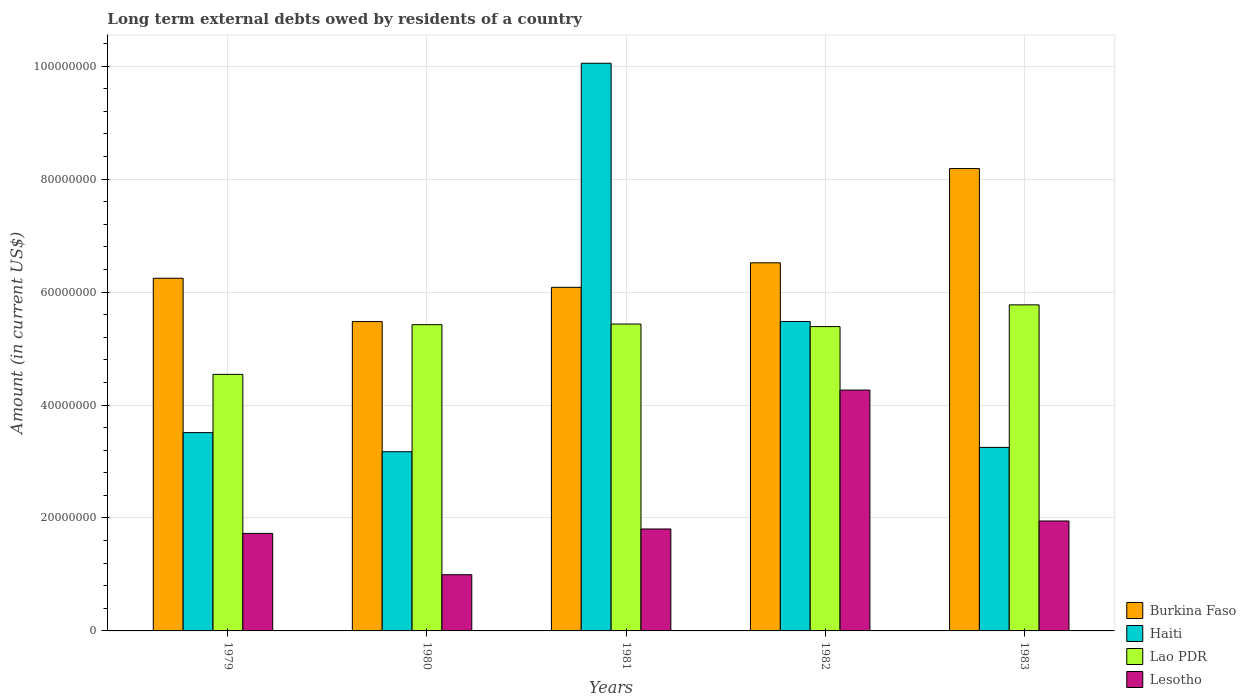How many different coloured bars are there?
Give a very brief answer. 4. How many groups of bars are there?
Your answer should be very brief. 5. Are the number of bars on each tick of the X-axis equal?
Keep it short and to the point. Yes. How many bars are there on the 3rd tick from the left?
Your answer should be compact. 4. What is the amount of long-term external debts owed by residents in Burkina Faso in 1982?
Give a very brief answer. 6.52e+07. Across all years, what is the maximum amount of long-term external debts owed by residents in Lao PDR?
Provide a short and direct response. 5.77e+07. Across all years, what is the minimum amount of long-term external debts owed by residents in Lao PDR?
Offer a very short reply. 4.54e+07. In which year was the amount of long-term external debts owed by residents in Lesotho minimum?
Your answer should be compact. 1980. What is the total amount of long-term external debts owed by residents in Haiti in the graph?
Your response must be concise. 2.55e+08. What is the difference between the amount of long-term external debts owed by residents in Lao PDR in 1982 and that in 1983?
Offer a terse response. -3.85e+06. What is the difference between the amount of long-term external debts owed by residents in Lao PDR in 1981 and the amount of long-term external debts owed by residents in Haiti in 1983?
Ensure brevity in your answer.  2.18e+07. What is the average amount of long-term external debts owed by residents in Haiti per year?
Ensure brevity in your answer.  5.09e+07. In the year 1982, what is the difference between the amount of long-term external debts owed by residents in Burkina Faso and amount of long-term external debts owed by residents in Haiti?
Your answer should be compact. 1.04e+07. In how many years, is the amount of long-term external debts owed by residents in Haiti greater than 68000000 US$?
Ensure brevity in your answer.  1. What is the ratio of the amount of long-term external debts owed by residents in Lao PDR in 1980 to that in 1983?
Provide a short and direct response. 0.94. What is the difference between the highest and the second highest amount of long-term external debts owed by residents in Lao PDR?
Offer a very short reply. 3.40e+06. What is the difference between the highest and the lowest amount of long-term external debts owed by residents in Lao PDR?
Provide a succinct answer. 1.23e+07. In how many years, is the amount of long-term external debts owed by residents in Burkina Faso greater than the average amount of long-term external debts owed by residents in Burkina Faso taken over all years?
Ensure brevity in your answer.  2. What does the 4th bar from the left in 1981 represents?
Make the answer very short. Lesotho. What does the 4th bar from the right in 1979 represents?
Keep it short and to the point. Burkina Faso. Is it the case that in every year, the sum of the amount of long-term external debts owed by residents in Burkina Faso and amount of long-term external debts owed by residents in Lao PDR is greater than the amount of long-term external debts owed by residents in Lesotho?
Your answer should be very brief. Yes. How many bars are there?
Keep it short and to the point. 20. How many years are there in the graph?
Your answer should be very brief. 5. Does the graph contain grids?
Ensure brevity in your answer.  Yes. How many legend labels are there?
Provide a succinct answer. 4. How are the legend labels stacked?
Offer a terse response. Vertical. What is the title of the graph?
Keep it short and to the point. Long term external debts owed by residents of a country. What is the Amount (in current US$) in Burkina Faso in 1979?
Make the answer very short. 6.24e+07. What is the Amount (in current US$) of Haiti in 1979?
Offer a terse response. 3.51e+07. What is the Amount (in current US$) in Lao PDR in 1979?
Offer a terse response. 4.54e+07. What is the Amount (in current US$) of Lesotho in 1979?
Give a very brief answer. 1.73e+07. What is the Amount (in current US$) of Burkina Faso in 1980?
Ensure brevity in your answer.  5.48e+07. What is the Amount (in current US$) in Haiti in 1980?
Give a very brief answer. 3.17e+07. What is the Amount (in current US$) of Lao PDR in 1980?
Your answer should be compact. 5.42e+07. What is the Amount (in current US$) of Lesotho in 1980?
Provide a succinct answer. 9.95e+06. What is the Amount (in current US$) in Burkina Faso in 1981?
Keep it short and to the point. 6.08e+07. What is the Amount (in current US$) in Haiti in 1981?
Your answer should be compact. 1.01e+08. What is the Amount (in current US$) in Lao PDR in 1981?
Your response must be concise. 5.43e+07. What is the Amount (in current US$) in Lesotho in 1981?
Your response must be concise. 1.80e+07. What is the Amount (in current US$) in Burkina Faso in 1982?
Offer a very short reply. 6.52e+07. What is the Amount (in current US$) in Haiti in 1982?
Provide a short and direct response. 5.48e+07. What is the Amount (in current US$) of Lao PDR in 1982?
Offer a very short reply. 5.39e+07. What is the Amount (in current US$) of Lesotho in 1982?
Provide a short and direct response. 4.26e+07. What is the Amount (in current US$) of Burkina Faso in 1983?
Your response must be concise. 8.19e+07. What is the Amount (in current US$) of Haiti in 1983?
Your answer should be very brief. 3.25e+07. What is the Amount (in current US$) in Lao PDR in 1983?
Offer a terse response. 5.77e+07. What is the Amount (in current US$) in Lesotho in 1983?
Your answer should be compact. 1.95e+07. Across all years, what is the maximum Amount (in current US$) of Burkina Faso?
Keep it short and to the point. 8.19e+07. Across all years, what is the maximum Amount (in current US$) of Haiti?
Keep it short and to the point. 1.01e+08. Across all years, what is the maximum Amount (in current US$) in Lao PDR?
Your response must be concise. 5.77e+07. Across all years, what is the maximum Amount (in current US$) in Lesotho?
Your response must be concise. 4.26e+07. Across all years, what is the minimum Amount (in current US$) in Burkina Faso?
Provide a short and direct response. 5.48e+07. Across all years, what is the minimum Amount (in current US$) in Haiti?
Your answer should be very brief. 3.17e+07. Across all years, what is the minimum Amount (in current US$) of Lao PDR?
Offer a terse response. 4.54e+07. Across all years, what is the minimum Amount (in current US$) of Lesotho?
Offer a very short reply. 9.95e+06. What is the total Amount (in current US$) in Burkina Faso in the graph?
Offer a very short reply. 3.25e+08. What is the total Amount (in current US$) in Haiti in the graph?
Your response must be concise. 2.55e+08. What is the total Amount (in current US$) of Lao PDR in the graph?
Offer a terse response. 2.66e+08. What is the total Amount (in current US$) of Lesotho in the graph?
Offer a very short reply. 1.07e+08. What is the difference between the Amount (in current US$) in Burkina Faso in 1979 and that in 1980?
Offer a very short reply. 7.67e+06. What is the difference between the Amount (in current US$) of Haiti in 1979 and that in 1980?
Your answer should be compact. 3.38e+06. What is the difference between the Amount (in current US$) in Lao PDR in 1979 and that in 1980?
Ensure brevity in your answer.  -8.80e+06. What is the difference between the Amount (in current US$) in Lesotho in 1979 and that in 1980?
Offer a very short reply. 7.32e+06. What is the difference between the Amount (in current US$) in Burkina Faso in 1979 and that in 1981?
Your response must be concise. 1.61e+06. What is the difference between the Amount (in current US$) of Haiti in 1979 and that in 1981?
Keep it short and to the point. -6.54e+07. What is the difference between the Amount (in current US$) of Lao PDR in 1979 and that in 1981?
Provide a succinct answer. -8.91e+06. What is the difference between the Amount (in current US$) in Lesotho in 1979 and that in 1981?
Keep it short and to the point. -7.84e+05. What is the difference between the Amount (in current US$) of Burkina Faso in 1979 and that in 1982?
Your answer should be compact. -2.73e+06. What is the difference between the Amount (in current US$) in Haiti in 1979 and that in 1982?
Give a very brief answer. -1.97e+07. What is the difference between the Amount (in current US$) in Lao PDR in 1979 and that in 1982?
Keep it short and to the point. -8.46e+06. What is the difference between the Amount (in current US$) in Lesotho in 1979 and that in 1982?
Offer a terse response. -2.54e+07. What is the difference between the Amount (in current US$) in Burkina Faso in 1979 and that in 1983?
Your answer should be very brief. -1.94e+07. What is the difference between the Amount (in current US$) in Haiti in 1979 and that in 1983?
Provide a succinct answer. 2.62e+06. What is the difference between the Amount (in current US$) in Lao PDR in 1979 and that in 1983?
Provide a succinct answer. -1.23e+07. What is the difference between the Amount (in current US$) in Lesotho in 1979 and that in 1983?
Provide a short and direct response. -2.20e+06. What is the difference between the Amount (in current US$) of Burkina Faso in 1980 and that in 1981?
Make the answer very short. -6.06e+06. What is the difference between the Amount (in current US$) in Haiti in 1980 and that in 1981?
Your answer should be compact. -6.88e+07. What is the difference between the Amount (in current US$) in Lao PDR in 1980 and that in 1981?
Your response must be concise. -1.11e+05. What is the difference between the Amount (in current US$) of Lesotho in 1980 and that in 1981?
Your response must be concise. -8.10e+06. What is the difference between the Amount (in current US$) in Burkina Faso in 1980 and that in 1982?
Provide a succinct answer. -1.04e+07. What is the difference between the Amount (in current US$) in Haiti in 1980 and that in 1982?
Your answer should be compact. -2.31e+07. What is the difference between the Amount (in current US$) of Lao PDR in 1980 and that in 1982?
Provide a succinct answer. 3.41e+05. What is the difference between the Amount (in current US$) of Lesotho in 1980 and that in 1982?
Your response must be concise. -3.27e+07. What is the difference between the Amount (in current US$) of Burkina Faso in 1980 and that in 1983?
Make the answer very short. -2.71e+07. What is the difference between the Amount (in current US$) in Haiti in 1980 and that in 1983?
Your answer should be compact. -7.66e+05. What is the difference between the Amount (in current US$) of Lao PDR in 1980 and that in 1983?
Keep it short and to the point. -3.51e+06. What is the difference between the Amount (in current US$) of Lesotho in 1980 and that in 1983?
Keep it short and to the point. -9.52e+06. What is the difference between the Amount (in current US$) of Burkina Faso in 1981 and that in 1982?
Provide a succinct answer. -4.34e+06. What is the difference between the Amount (in current US$) in Haiti in 1981 and that in 1982?
Your answer should be very brief. 4.57e+07. What is the difference between the Amount (in current US$) in Lao PDR in 1981 and that in 1982?
Provide a succinct answer. 4.52e+05. What is the difference between the Amount (in current US$) in Lesotho in 1981 and that in 1982?
Offer a terse response. -2.46e+07. What is the difference between the Amount (in current US$) of Burkina Faso in 1981 and that in 1983?
Offer a very short reply. -2.10e+07. What is the difference between the Amount (in current US$) of Haiti in 1981 and that in 1983?
Your response must be concise. 6.80e+07. What is the difference between the Amount (in current US$) in Lao PDR in 1981 and that in 1983?
Offer a very short reply. -3.40e+06. What is the difference between the Amount (in current US$) of Lesotho in 1981 and that in 1983?
Provide a succinct answer. -1.42e+06. What is the difference between the Amount (in current US$) of Burkina Faso in 1982 and that in 1983?
Keep it short and to the point. -1.67e+07. What is the difference between the Amount (in current US$) of Haiti in 1982 and that in 1983?
Make the answer very short. 2.23e+07. What is the difference between the Amount (in current US$) of Lao PDR in 1982 and that in 1983?
Your answer should be very brief. -3.85e+06. What is the difference between the Amount (in current US$) in Lesotho in 1982 and that in 1983?
Give a very brief answer. 2.32e+07. What is the difference between the Amount (in current US$) of Burkina Faso in 1979 and the Amount (in current US$) of Haiti in 1980?
Make the answer very short. 3.07e+07. What is the difference between the Amount (in current US$) of Burkina Faso in 1979 and the Amount (in current US$) of Lao PDR in 1980?
Your response must be concise. 8.22e+06. What is the difference between the Amount (in current US$) of Burkina Faso in 1979 and the Amount (in current US$) of Lesotho in 1980?
Keep it short and to the point. 5.25e+07. What is the difference between the Amount (in current US$) of Haiti in 1979 and the Amount (in current US$) of Lao PDR in 1980?
Your response must be concise. -1.91e+07. What is the difference between the Amount (in current US$) in Haiti in 1979 and the Amount (in current US$) in Lesotho in 1980?
Provide a succinct answer. 2.52e+07. What is the difference between the Amount (in current US$) in Lao PDR in 1979 and the Amount (in current US$) in Lesotho in 1980?
Your response must be concise. 3.55e+07. What is the difference between the Amount (in current US$) in Burkina Faso in 1979 and the Amount (in current US$) in Haiti in 1981?
Ensure brevity in your answer.  -3.81e+07. What is the difference between the Amount (in current US$) in Burkina Faso in 1979 and the Amount (in current US$) in Lao PDR in 1981?
Your answer should be very brief. 8.11e+06. What is the difference between the Amount (in current US$) of Burkina Faso in 1979 and the Amount (in current US$) of Lesotho in 1981?
Your answer should be compact. 4.44e+07. What is the difference between the Amount (in current US$) of Haiti in 1979 and the Amount (in current US$) of Lao PDR in 1981?
Ensure brevity in your answer.  -1.92e+07. What is the difference between the Amount (in current US$) in Haiti in 1979 and the Amount (in current US$) in Lesotho in 1981?
Ensure brevity in your answer.  1.71e+07. What is the difference between the Amount (in current US$) in Lao PDR in 1979 and the Amount (in current US$) in Lesotho in 1981?
Ensure brevity in your answer.  2.74e+07. What is the difference between the Amount (in current US$) in Burkina Faso in 1979 and the Amount (in current US$) in Haiti in 1982?
Your answer should be compact. 7.66e+06. What is the difference between the Amount (in current US$) of Burkina Faso in 1979 and the Amount (in current US$) of Lao PDR in 1982?
Your answer should be compact. 8.56e+06. What is the difference between the Amount (in current US$) in Burkina Faso in 1979 and the Amount (in current US$) in Lesotho in 1982?
Your response must be concise. 1.98e+07. What is the difference between the Amount (in current US$) of Haiti in 1979 and the Amount (in current US$) of Lao PDR in 1982?
Keep it short and to the point. -1.88e+07. What is the difference between the Amount (in current US$) of Haiti in 1979 and the Amount (in current US$) of Lesotho in 1982?
Your answer should be very brief. -7.53e+06. What is the difference between the Amount (in current US$) in Lao PDR in 1979 and the Amount (in current US$) in Lesotho in 1982?
Ensure brevity in your answer.  2.78e+06. What is the difference between the Amount (in current US$) in Burkina Faso in 1979 and the Amount (in current US$) in Haiti in 1983?
Provide a succinct answer. 3.00e+07. What is the difference between the Amount (in current US$) of Burkina Faso in 1979 and the Amount (in current US$) of Lao PDR in 1983?
Keep it short and to the point. 4.71e+06. What is the difference between the Amount (in current US$) in Burkina Faso in 1979 and the Amount (in current US$) in Lesotho in 1983?
Your answer should be very brief. 4.30e+07. What is the difference between the Amount (in current US$) of Haiti in 1979 and the Amount (in current US$) of Lao PDR in 1983?
Provide a short and direct response. -2.26e+07. What is the difference between the Amount (in current US$) of Haiti in 1979 and the Amount (in current US$) of Lesotho in 1983?
Give a very brief answer. 1.56e+07. What is the difference between the Amount (in current US$) in Lao PDR in 1979 and the Amount (in current US$) in Lesotho in 1983?
Give a very brief answer. 2.60e+07. What is the difference between the Amount (in current US$) of Burkina Faso in 1980 and the Amount (in current US$) of Haiti in 1981?
Provide a succinct answer. -4.57e+07. What is the difference between the Amount (in current US$) of Burkina Faso in 1980 and the Amount (in current US$) of Lao PDR in 1981?
Offer a terse response. 4.36e+05. What is the difference between the Amount (in current US$) of Burkina Faso in 1980 and the Amount (in current US$) of Lesotho in 1981?
Give a very brief answer. 3.67e+07. What is the difference between the Amount (in current US$) of Haiti in 1980 and the Amount (in current US$) of Lao PDR in 1981?
Offer a terse response. -2.26e+07. What is the difference between the Amount (in current US$) in Haiti in 1980 and the Amount (in current US$) in Lesotho in 1981?
Offer a very short reply. 1.37e+07. What is the difference between the Amount (in current US$) in Lao PDR in 1980 and the Amount (in current US$) in Lesotho in 1981?
Give a very brief answer. 3.62e+07. What is the difference between the Amount (in current US$) of Burkina Faso in 1980 and the Amount (in current US$) of Haiti in 1982?
Ensure brevity in your answer.  -7000. What is the difference between the Amount (in current US$) of Burkina Faso in 1980 and the Amount (in current US$) of Lao PDR in 1982?
Your answer should be compact. 8.88e+05. What is the difference between the Amount (in current US$) in Burkina Faso in 1980 and the Amount (in current US$) in Lesotho in 1982?
Your response must be concise. 1.21e+07. What is the difference between the Amount (in current US$) of Haiti in 1980 and the Amount (in current US$) of Lao PDR in 1982?
Offer a very short reply. -2.22e+07. What is the difference between the Amount (in current US$) in Haiti in 1980 and the Amount (in current US$) in Lesotho in 1982?
Make the answer very short. -1.09e+07. What is the difference between the Amount (in current US$) in Lao PDR in 1980 and the Amount (in current US$) in Lesotho in 1982?
Keep it short and to the point. 1.16e+07. What is the difference between the Amount (in current US$) of Burkina Faso in 1980 and the Amount (in current US$) of Haiti in 1983?
Make the answer very short. 2.23e+07. What is the difference between the Amount (in current US$) of Burkina Faso in 1980 and the Amount (in current US$) of Lao PDR in 1983?
Your response must be concise. -2.96e+06. What is the difference between the Amount (in current US$) in Burkina Faso in 1980 and the Amount (in current US$) in Lesotho in 1983?
Give a very brief answer. 3.53e+07. What is the difference between the Amount (in current US$) of Haiti in 1980 and the Amount (in current US$) of Lao PDR in 1983?
Keep it short and to the point. -2.60e+07. What is the difference between the Amount (in current US$) in Haiti in 1980 and the Amount (in current US$) in Lesotho in 1983?
Ensure brevity in your answer.  1.23e+07. What is the difference between the Amount (in current US$) of Lao PDR in 1980 and the Amount (in current US$) of Lesotho in 1983?
Your response must be concise. 3.48e+07. What is the difference between the Amount (in current US$) of Burkina Faso in 1981 and the Amount (in current US$) of Haiti in 1982?
Offer a very short reply. 6.06e+06. What is the difference between the Amount (in current US$) in Burkina Faso in 1981 and the Amount (in current US$) in Lao PDR in 1982?
Offer a very short reply. 6.95e+06. What is the difference between the Amount (in current US$) in Burkina Faso in 1981 and the Amount (in current US$) in Lesotho in 1982?
Ensure brevity in your answer.  1.82e+07. What is the difference between the Amount (in current US$) in Haiti in 1981 and the Amount (in current US$) in Lao PDR in 1982?
Your answer should be compact. 4.66e+07. What is the difference between the Amount (in current US$) in Haiti in 1981 and the Amount (in current US$) in Lesotho in 1982?
Your answer should be very brief. 5.79e+07. What is the difference between the Amount (in current US$) of Lao PDR in 1981 and the Amount (in current US$) of Lesotho in 1982?
Provide a succinct answer. 1.17e+07. What is the difference between the Amount (in current US$) in Burkina Faso in 1981 and the Amount (in current US$) in Haiti in 1983?
Offer a terse response. 2.83e+07. What is the difference between the Amount (in current US$) of Burkina Faso in 1981 and the Amount (in current US$) of Lao PDR in 1983?
Make the answer very short. 3.10e+06. What is the difference between the Amount (in current US$) in Burkina Faso in 1981 and the Amount (in current US$) in Lesotho in 1983?
Make the answer very short. 4.14e+07. What is the difference between the Amount (in current US$) of Haiti in 1981 and the Amount (in current US$) of Lao PDR in 1983?
Provide a succinct answer. 4.28e+07. What is the difference between the Amount (in current US$) in Haiti in 1981 and the Amount (in current US$) in Lesotho in 1983?
Your response must be concise. 8.10e+07. What is the difference between the Amount (in current US$) of Lao PDR in 1981 and the Amount (in current US$) of Lesotho in 1983?
Provide a succinct answer. 3.49e+07. What is the difference between the Amount (in current US$) in Burkina Faso in 1982 and the Amount (in current US$) in Haiti in 1983?
Provide a succinct answer. 3.27e+07. What is the difference between the Amount (in current US$) in Burkina Faso in 1982 and the Amount (in current US$) in Lao PDR in 1983?
Your answer should be very brief. 7.44e+06. What is the difference between the Amount (in current US$) in Burkina Faso in 1982 and the Amount (in current US$) in Lesotho in 1983?
Your answer should be compact. 4.57e+07. What is the difference between the Amount (in current US$) in Haiti in 1982 and the Amount (in current US$) in Lao PDR in 1983?
Provide a succinct answer. -2.95e+06. What is the difference between the Amount (in current US$) of Haiti in 1982 and the Amount (in current US$) of Lesotho in 1983?
Offer a very short reply. 3.53e+07. What is the difference between the Amount (in current US$) of Lao PDR in 1982 and the Amount (in current US$) of Lesotho in 1983?
Keep it short and to the point. 3.44e+07. What is the average Amount (in current US$) of Burkina Faso per year?
Offer a very short reply. 6.50e+07. What is the average Amount (in current US$) in Haiti per year?
Your answer should be very brief. 5.09e+07. What is the average Amount (in current US$) in Lao PDR per year?
Keep it short and to the point. 5.31e+07. What is the average Amount (in current US$) of Lesotho per year?
Your answer should be compact. 2.15e+07. In the year 1979, what is the difference between the Amount (in current US$) in Burkina Faso and Amount (in current US$) in Haiti?
Provide a succinct answer. 2.73e+07. In the year 1979, what is the difference between the Amount (in current US$) of Burkina Faso and Amount (in current US$) of Lao PDR?
Give a very brief answer. 1.70e+07. In the year 1979, what is the difference between the Amount (in current US$) in Burkina Faso and Amount (in current US$) in Lesotho?
Provide a short and direct response. 4.52e+07. In the year 1979, what is the difference between the Amount (in current US$) in Haiti and Amount (in current US$) in Lao PDR?
Provide a short and direct response. -1.03e+07. In the year 1979, what is the difference between the Amount (in current US$) of Haiti and Amount (in current US$) of Lesotho?
Your answer should be very brief. 1.78e+07. In the year 1979, what is the difference between the Amount (in current US$) of Lao PDR and Amount (in current US$) of Lesotho?
Provide a short and direct response. 2.82e+07. In the year 1980, what is the difference between the Amount (in current US$) of Burkina Faso and Amount (in current US$) of Haiti?
Offer a terse response. 2.30e+07. In the year 1980, what is the difference between the Amount (in current US$) in Burkina Faso and Amount (in current US$) in Lao PDR?
Provide a short and direct response. 5.47e+05. In the year 1980, what is the difference between the Amount (in current US$) in Burkina Faso and Amount (in current US$) in Lesotho?
Provide a short and direct response. 4.48e+07. In the year 1980, what is the difference between the Amount (in current US$) in Haiti and Amount (in current US$) in Lao PDR?
Your answer should be very brief. -2.25e+07. In the year 1980, what is the difference between the Amount (in current US$) in Haiti and Amount (in current US$) in Lesotho?
Your response must be concise. 2.18e+07. In the year 1980, what is the difference between the Amount (in current US$) in Lao PDR and Amount (in current US$) in Lesotho?
Give a very brief answer. 4.43e+07. In the year 1981, what is the difference between the Amount (in current US$) of Burkina Faso and Amount (in current US$) of Haiti?
Offer a very short reply. -3.97e+07. In the year 1981, what is the difference between the Amount (in current US$) of Burkina Faso and Amount (in current US$) of Lao PDR?
Provide a succinct answer. 6.50e+06. In the year 1981, what is the difference between the Amount (in current US$) in Burkina Faso and Amount (in current US$) in Lesotho?
Provide a succinct answer. 4.28e+07. In the year 1981, what is the difference between the Amount (in current US$) in Haiti and Amount (in current US$) in Lao PDR?
Ensure brevity in your answer.  4.62e+07. In the year 1981, what is the difference between the Amount (in current US$) of Haiti and Amount (in current US$) of Lesotho?
Your answer should be very brief. 8.25e+07. In the year 1981, what is the difference between the Amount (in current US$) in Lao PDR and Amount (in current US$) in Lesotho?
Offer a very short reply. 3.63e+07. In the year 1982, what is the difference between the Amount (in current US$) in Burkina Faso and Amount (in current US$) in Haiti?
Your answer should be compact. 1.04e+07. In the year 1982, what is the difference between the Amount (in current US$) of Burkina Faso and Amount (in current US$) of Lao PDR?
Your answer should be compact. 1.13e+07. In the year 1982, what is the difference between the Amount (in current US$) of Burkina Faso and Amount (in current US$) of Lesotho?
Your answer should be very brief. 2.25e+07. In the year 1982, what is the difference between the Amount (in current US$) of Haiti and Amount (in current US$) of Lao PDR?
Offer a very short reply. 8.95e+05. In the year 1982, what is the difference between the Amount (in current US$) in Haiti and Amount (in current US$) in Lesotho?
Provide a short and direct response. 1.21e+07. In the year 1982, what is the difference between the Amount (in current US$) in Lao PDR and Amount (in current US$) in Lesotho?
Provide a short and direct response. 1.12e+07. In the year 1983, what is the difference between the Amount (in current US$) of Burkina Faso and Amount (in current US$) of Haiti?
Make the answer very short. 4.94e+07. In the year 1983, what is the difference between the Amount (in current US$) of Burkina Faso and Amount (in current US$) of Lao PDR?
Offer a terse response. 2.41e+07. In the year 1983, what is the difference between the Amount (in current US$) in Burkina Faso and Amount (in current US$) in Lesotho?
Ensure brevity in your answer.  6.24e+07. In the year 1983, what is the difference between the Amount (in current US$) of Haiti and Amount (in current US$) of Lao PDR?
Make the answer very short. -2.52e+07. In the year 1983, what is the difference between the Amount (in current US$) in Haiti and Amount (in current US$) in Lesotho?
Make the answer very short. 1.30e+07. In the year 1983, what is the difference between the Amount (in current US$) of Lao PDR and Amount (in current US$) of Lesotho?
Offer a terse response. 3.83e+07. What is the ratio of the Amount (in current US$) in Burkina Faso in 1979 to that in 1980?
Provide a short and direct response. 1.14. What is the ratio of the Amount (in current US$) in Haiti in 1979 to that in 1980?
Offer a very short reply. 1.11. What is the ratio of the Amount (in current US$) in Lao PDR in 1979 to that in 1980?
Ensure brevity in your answer.  0.84. What is the ratio of the Amount (in current US$) in Lesotho in 1979 to that in 1980?
Ensure brevity in your answer.  1.74. What is the ratio of the Amount (in current US$) in Burkina Faso in 1979 to that in 1981?
Your answer should be compact. 1.03. What is the ratio of the Amount (in current US$) of Haiti in 1979 to that in 1981?
Offer a very short reply. 0.35. What is the ratio of the Amount (in current US$) in Lao PDR in 1979 to that in 1981?
Your answer should be compact. 0.84. What is the ratio of the Amount (in current US$) of Lesotho in 1979 to that in 1981?
Your response must be concise. 0.96. What is the ratio of the Amount (in current US$) of Burkina Faso in 1979 to that in 1982?
Keep it short and to the point. 0.96. What is the ratio of the Amount (in current US$) in Haiti in 1979 to that in 1982?
Keep it short and to the point. 0.64. What is the ratio of the Amount (in current US$) in Lao PDR in 1979 to that in 1982?
Your response must be concise. 0.84. What is the ratio of the Amount (in current US$) in Lesotho in 1979 to that in 1982?
Make the answer very short. 0.4. What is the ratio of the Amount (in current US$) in Burkina Faso in 1979 to that in 1983?
Offer a terse response. 0.76. What is the ratio of the Amount (in current US$) in Haiti in 1979 to that in 1983?
Your answer should be compact. 1.08. What is the ratio of the Amount (in current US$) in Lao PDR in 1979 to that in 1983?
Your response must be concise. 0.79. What is the ratio of the Amount (in current US$) of Lesotho in 1979 to that in 1983?
Your answer should be compact. 0.89. What is the ratio of the Amount (in current US$) in Burkina Faso in 1980 to that in 1981?
Give a very brief answer. 0.9. What is the ratio of the Amount (in current US$) in Haiti in 1980 to that in 1981?
Your answer should be very brief. 0.32. What is the ratio of the Amount (in current US$) of Lesotho in 1980 to that in 1981?
Your answer should be very brief. 0.55. What is the ratio of the Amount (in current US$) of Burkina Faso in 1980 to that in 1982?
Make the answer very short. 0.84. What is the ratio of the Amount (in current US$) of Haiti in 1980 to that in 1982?
Offer a terse response. 0.58. What is the ratio of the Amount (in current US$) in Lao PDR in 1980 to that in 1982?
Provide a short and direct response. 1.01. What is the ratio of the Amount (in current US$) of Lesotho in 1980 to that in 1982?
Provide a short and direct response. 0.23. What is the ratio of the Amount (in current US$) of Burkina Faso in 1980 to that in 1983?
Your response must be concise. 0.67. What is the ratio of the Amount (in current US$) of Haiti in 1980 to that in 1983?
Offer a very short reply. 0.98. What is the ratio of the Amount (in current US$) in Lao PDR in 1980 to that in 1983?
Provide a succinct answer. 0.94. What is the ratio of the Amount (in current US$) in Lesotho in 1980 to that in 1983?
Provide a short and direct response. 0.51. What is the ratio of the Amount (in current US$) in Burkina Faso in 1981 to that in 1982?
Offer a very short reply. 0.93. What is the ratio of the Amount (in current US$) of Haiti in 1981 to that in 1982?
Provide a succinct answer. 1.83. What is the ratio of the Amount (in current US$) of Lao PDR in 1981 to that in 1982?
Ensure brevity in your answer.  1.01. What is the ratio of the Amount (in current US$) of Lesotho in 1981 to that in 1982?
Offer a very short reply. 0.42. What is the ratio of the Amount (in current US$) in Burkina Faso in 1981 to that in 1983?
Offer a terse response. 0.74. What is the ratio of the Amount (in current US$) in Haiti in 1981 to that in 1983?
Your answer should be very brief. 3.09. What is the ratio of the Amount (in current US$) in Lao PDR in 1981 to that in 1983?
Give a very brief answer. 0.94. What is the ratio of the Amount (in current US$) of Lesotho in 1981 to that in 1983?
Provide a short and direct response. 0.93. What is the ratio of the Amount (in current US$) of Burkina Faso in 1982 to that in 1983?
Offer a terse response. 0.8. What is the ratio of the Amount (in current US$) of Haiti in 1982 to that in 1983?
Offer a very short reply. 1.69. What is the ratio of the Amount (in current US$) in Lao PDR in 1982 to that in 1983?
Make the answer very short. 0.93. What is the ratio of the Amount (in current US$) in Lesotho in 1982 to that in 1983?
Your answer should be very brief. 2.19. What is the difference between the highest and the second highest Amount (in current US$) in Burkina Faso?
Your answer should be compact. 1.67e+07. What is the difference between the highest and the second highest Amount (in current US$) of Haiti?
Give a very brief answer. 4.57e+07. What is the difference between the highest and the second highest Amount (in current US$) of Lao PDR?
Provide a short and direct response. 3.40e+06. What is the difference between the highest and the second highest Amount (in current US$) of Lesotho?
Give a very brief answer. 2.32e+07. What is the difference between the highest and the lowest Amount (in current US$) of Burkina Faso?
Keep it short and to the point. 2.71e+07. What is the difference between the highest and the lowest Amount (in current US$) of Haiti?
Make the answer very short. 6.88e+07. What is the difference between the highest and the lowest Amount (in current US$) of Lao PDR?
Your response must be concise. 1.23e+07. What is the difference between the highest and the lowest Amount (in current US$) in Lesotho?
Make the answer very short. 3.27e+07. 